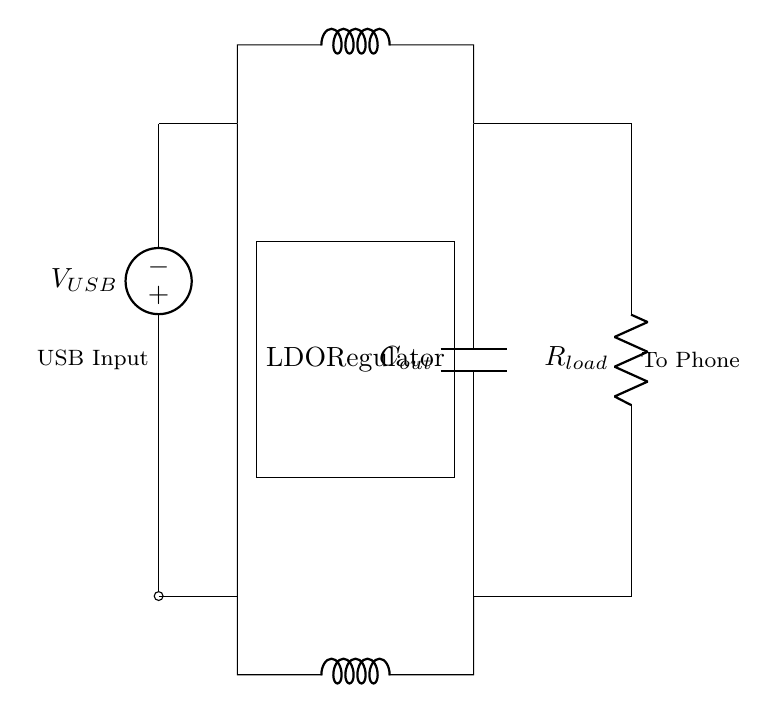What is the main component used to regulate voltage? The main component to regulate voltage in this circuit is the LDO Regulator, which is specifically designed to keep the output voltage stable.
Answer: LDO Regulator What does the symbol "C" represent in the diagram? The symbol "C" in the diagram represents a capacitor, specifically the output capacitor, which helps filter and stabilize the output voltage supplied to the load.
Answer: Capacitor What is the purpose of the inductor in this circuit? The inductors in this circuit are used to smooth voltage fluctuations, providing a more stable current by reducing noise and ripple in the output.
Answer: Smooth voltage What voltage is expected at the output of the LDO regulator? The output voltage of the LDO regulator is typically lower than the input voltage, specifically designed to deliver a steady voltage, often 5 volts for USB charging applications.
Answer: 5 volts How many resistances are present in the circuit? There is one resistor present in the circuit, which acts as the load for the phone being charged.
Answer: One resistor What does the load represent in this circuit? The load represents the phone being charged, symbolized by the resistor, which consumes power provided by the circuit through the regulated output voltage.
Answer: Phone load What connects the USB input to the voltage regulator? A short wire connects the USB input to the voltage regulator, providing the necessary current for voltage regulation and ensuring a proper supply to the circuit.
Answer: Short wire 